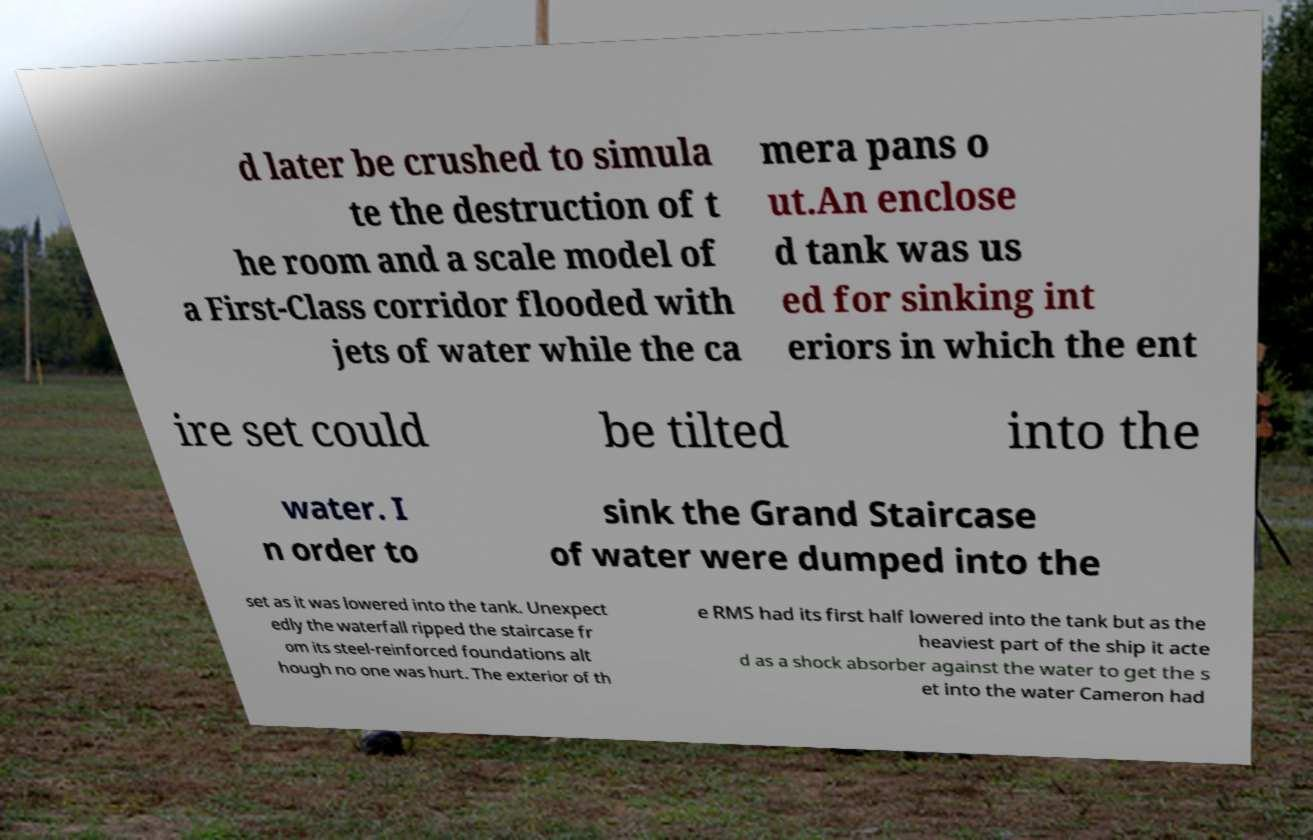There's text embedded in this image that I need extracted. Can you transcribe it verbatim? d later be crushed to simula te the destruction of t he room and a scale model of a First-Class corridor flooded with jets of water while the ca mera pans o ut.An enclose d tank was us ed for sinking int eriors in which the ent ire set could be tilted into the water. I n order to sink the Grand Staircase of water were dumped into the set as it was lowered into the tank. Unexpect edly the waterfall ripped the staircase fr om its steel-reinforced foundations alt hough no one was hurt. The exterior of th e RMS had its first half lowered into the tank but as the heaviest part of the ship it acte d as a shock absorber against the water to get the s et into the water Cameron had 